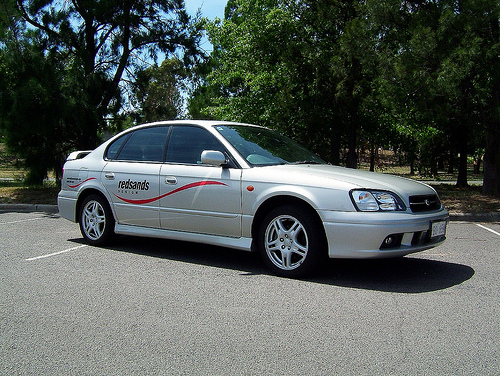<image>
Is there a car behind the tree? No. The car is not behind the tree. From this viewpoint, the car appears to be positioned elsewhere in the scene. 